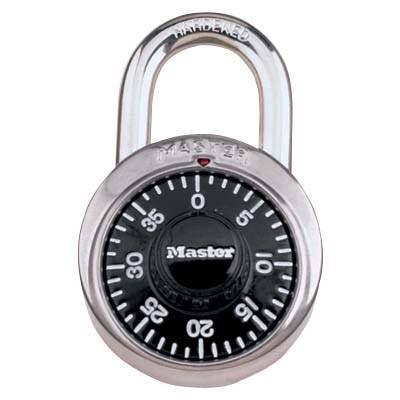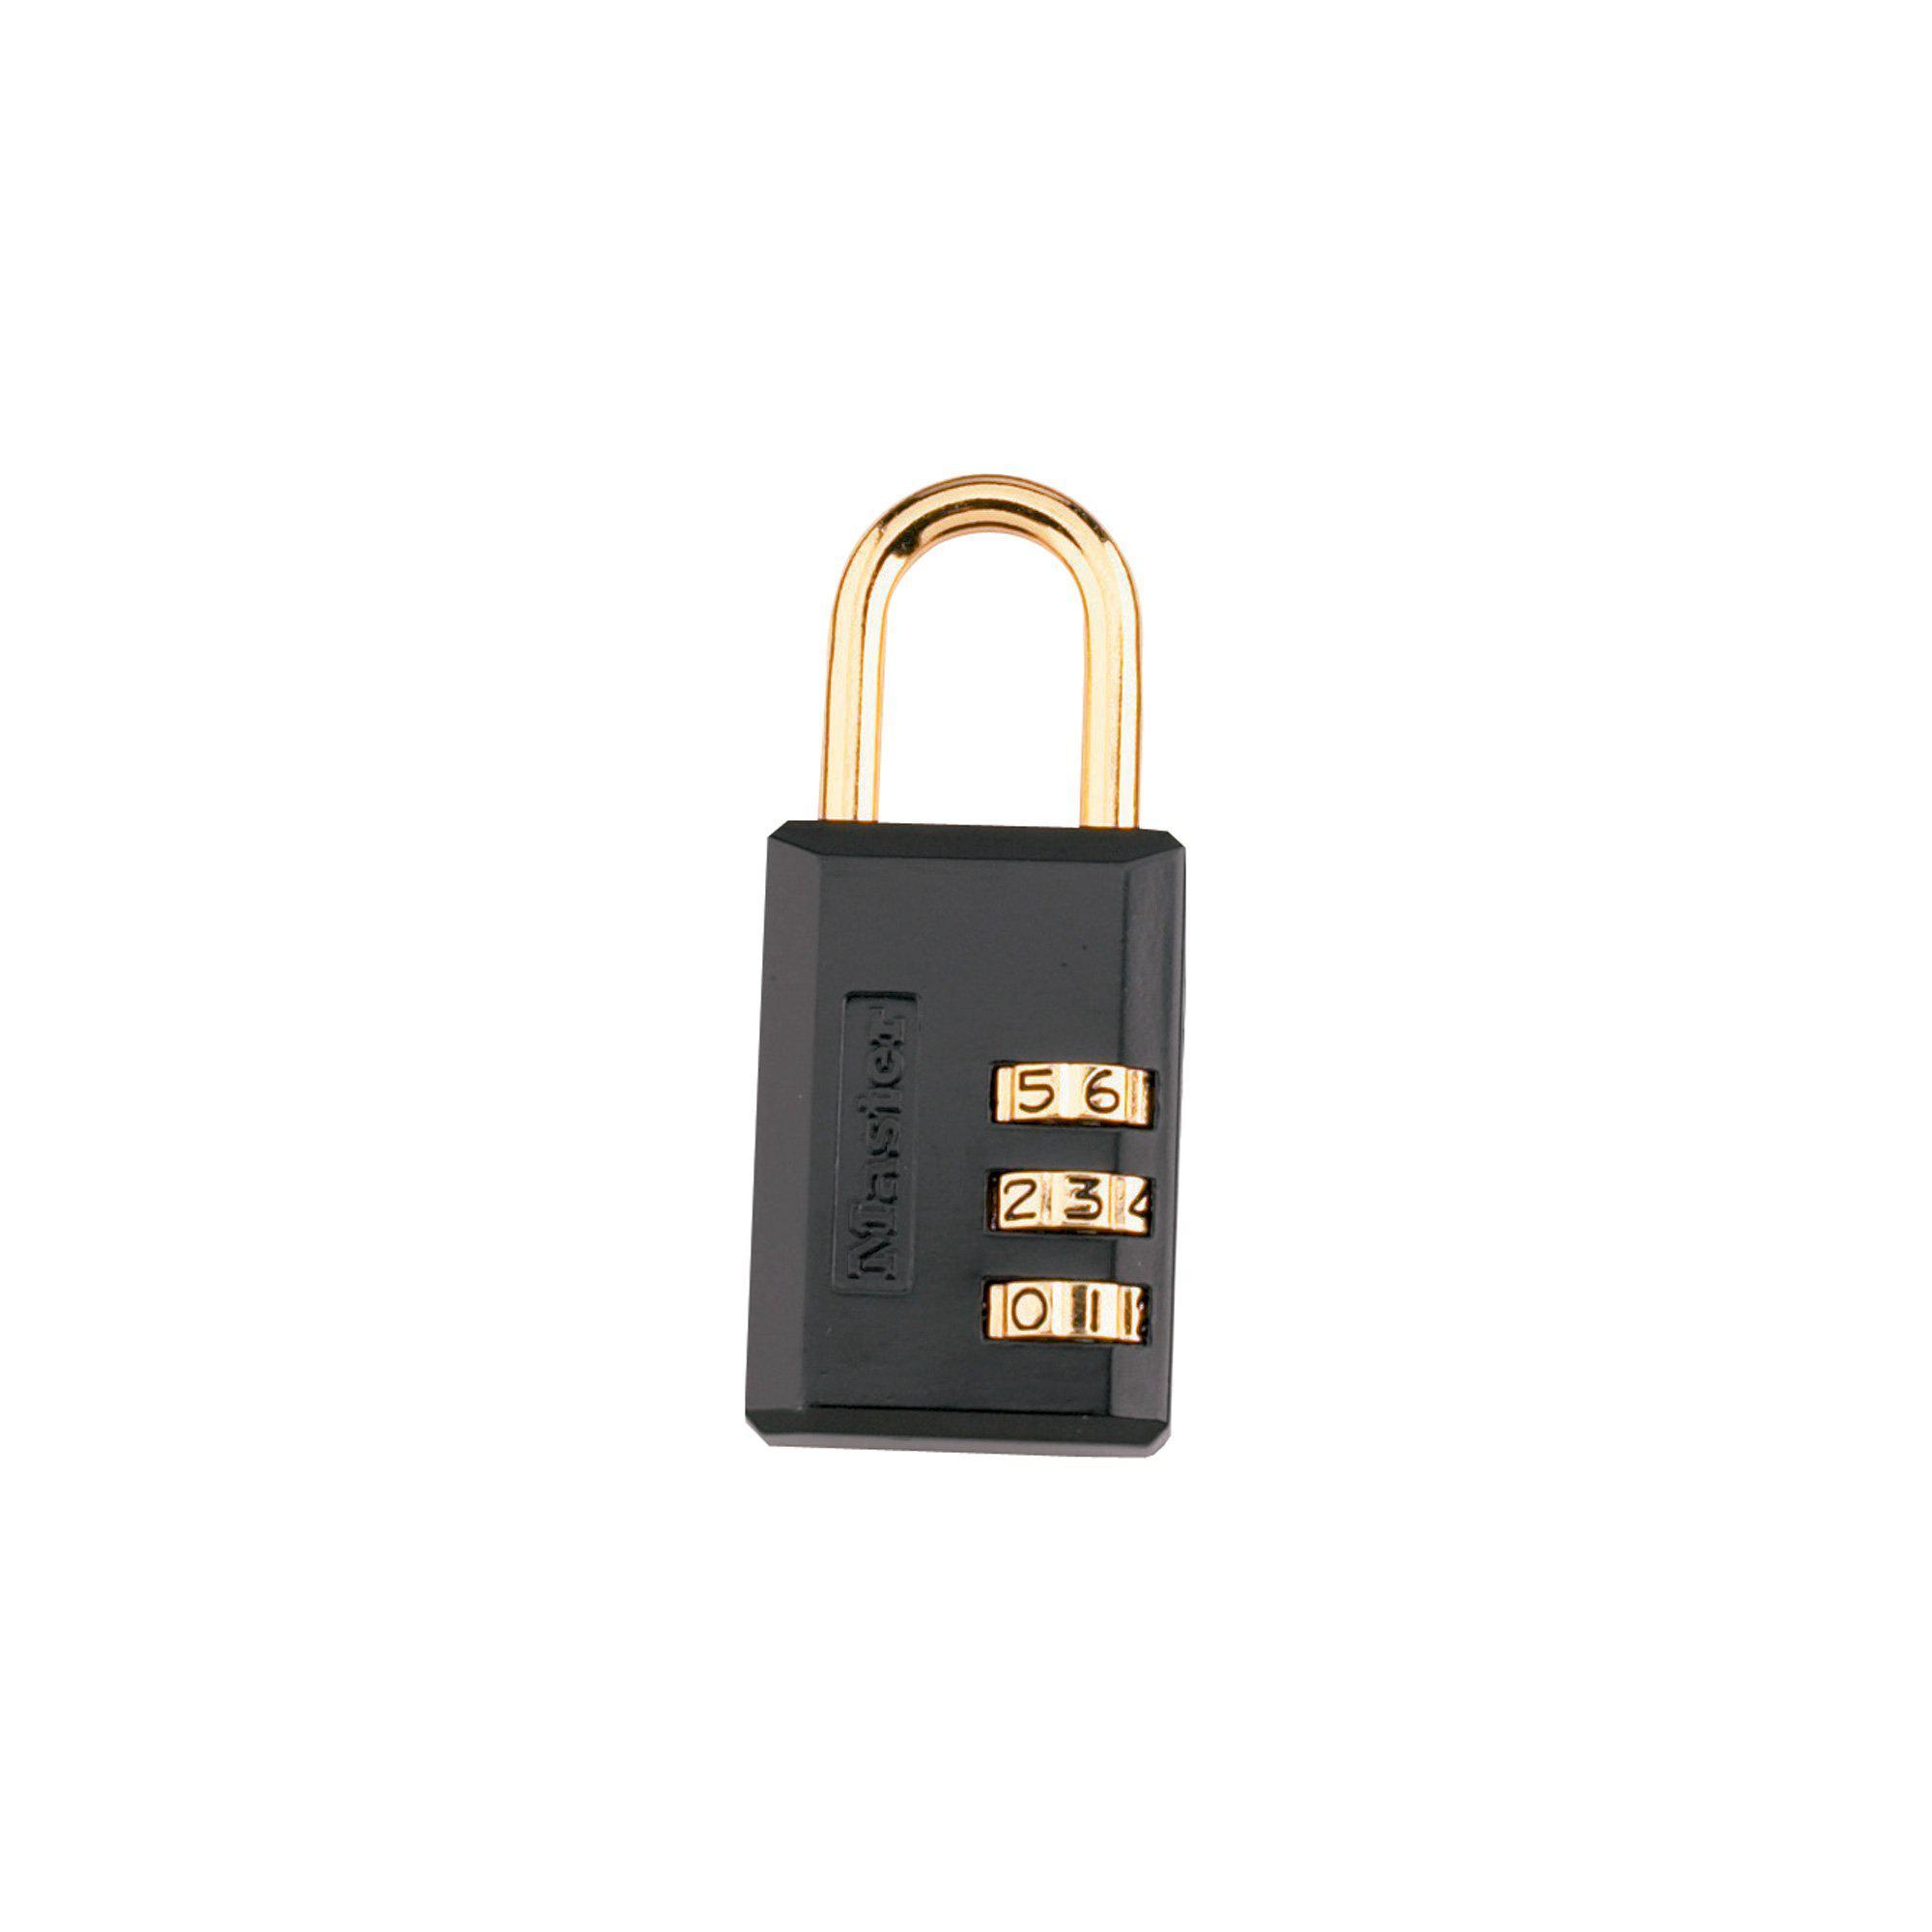The first image is the image on the left, the second image is the image on the right. Evaluate the accuracy of this statement regarding the images: "Images contain a total of at least two rectangular silver-colored combination locks.". Is it true? Answer yes or no. No. 